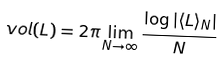Convert formula to latex. <formula><loc_0><loc_0><loc_500><loc_500>\ v o l ( L ) = 2 \pi \lim _ { N \to \infty } \frac { \log \left | \langle L \rangle _ { N } \right | } { N }</formula> 